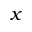Convert formula to latex. <formula><loc_0><loc_0><loc_500><loc_500>x</formula> 